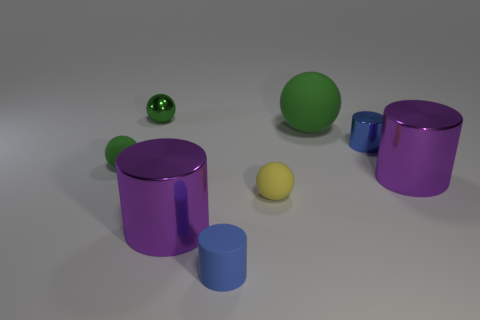How many green balls must be subtracted to get 1 green balls? 2 Subtract all big spheres. How many spheres are left? 3 Subtract 1 balls. How many balls are left? 3 Subtract all yellow blocks. How many green balls are left? 3 Subtract all yellow spheres. How many spheres are left? 3 Add 1 large purple objects. How many objects exist? 9 Subtract all yellow spheres. Subtract all green cubes. How many spheres are left? 3 Add 5 tiny blue metallic things. How many tiny blue metallic things exist? 6 Subtract 0 yellow cylinders. How many objects are left? 8 Subtract all small yellow balls. Subtract all large green rubber objects. How many objects are left? 6 